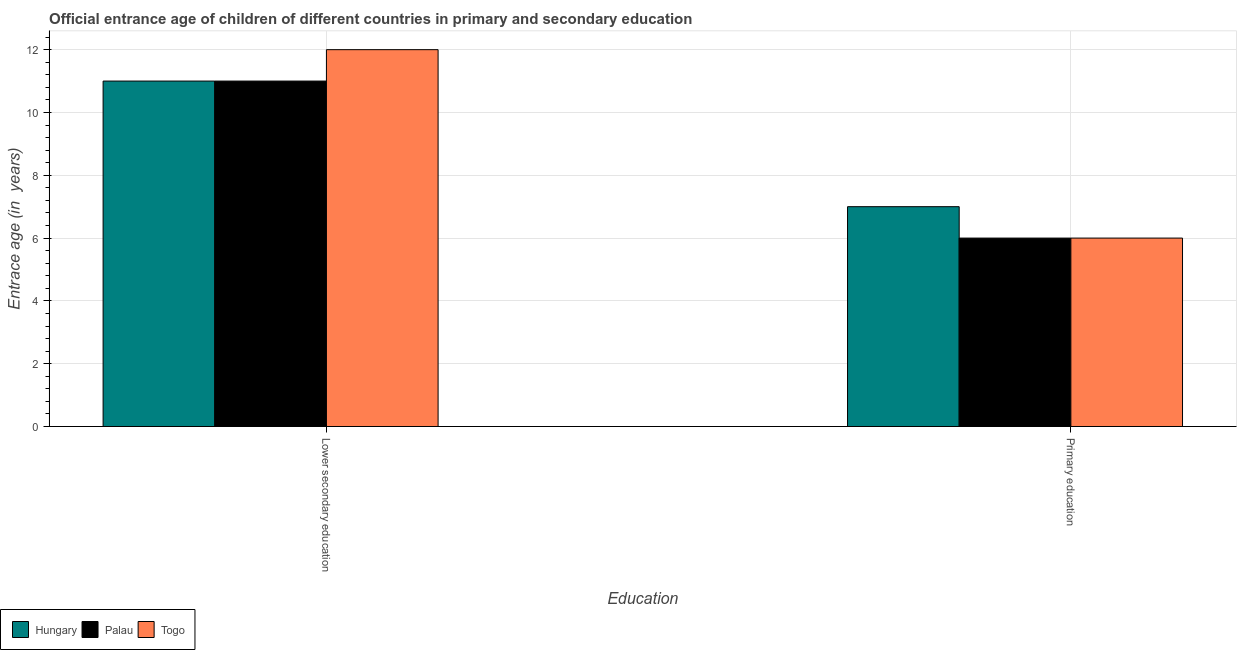How many bars are there on the 1st tick from the right?
Provide a short and direct response. 3. What is the entrance age of children in lower secondary education in Togo?
Make the answer very short. 12. Across all countries, what is the maximum entrance age of chiildren in primary education?
Your answer should be compact. 7. In which country was the entrance age of children in lower secondary education maximum?
Offer a very short reply. Togo. In which country was the entrance age of children in lower secondary education minimum?
Give a very brief answer. Hungary. What is the total entrance age of children in lower secondary education in the graph?
Your answer should be compact. 34. What is the difference between the entrance age of children in lower secondary education in Hungary and that in Togo?
Your answer should be very brief. -1. What is the average entrance age of children in lower secondary education per country?
Ensure brevity in your answer.  11.33. What is the difference between the entrance age of children in lower secondary education and entrance age of chiildren in primary education in Togo?
Provide a succinct answer. 6. In how many countries, is the entrance age of children in lower secondary education greater than 6.8 years?
Your answer should be very brief. 3. What does the 2nd bar from the left in Primary education represents?
Make the answer very short. Palau. What does the 2nd bar from the right in Primary education represents?
Your response must be concise. Palau. Are all the bars in the graph horizontal?
Your response must be concise. No. How many countries are there in the graph?
Keep it short and to the point. 3. Are the values on the major ticks of Y-axis written in scientific E-notation?
Make the answer very short. No. Does the graph contain any zero values?
Provide a short and direct response. No. Where does the legend appear in the graph?
Your answer should be compact. Bottom left. How many legend labels are there?
Offer a terse response. 3. How are the legend labels stacked?
Give a very brief answer. Horizontal. What is the title of the graph?
Your answer should be compact. Official entrance age of children of different countries in primary and secondary education. Does "Luxembourg" appear as one of the legend labels in the graph?
Make the answer very short. No. What is the label or title of the X-axis?
Provide a short and direct response. Education. What is the label or title of the Y-axis?
Provide a short and direct response. Entrace age (in  years). What is the Entrace age (in  years) of Hungary in Lower secondary education?
Your answer should be compact. 11. What is the Entrace age (in  years) in Palau in Lower secondary education?
Your response must be concise. 11. What is the Entrace age (in  years) of Togo in Lower secondary education?
Make the answer very short. 12. What is the Entrace age (in  years) in Palau in Primary education?
Ensure brevity in your answer.  6. Across all Education, what is the maximum Entrace age (in  years) of Hungary?
Your answer should be very brief. 11. Across all Education, what is the maximum Entrace age (in  years) in Palau?
Offer a very short reply. 11. Across all Education, what is the minimum Entrace age (in  years) in Palau?
Make the answer very short. 6. What is the total Entrace age (in  years) in Hungary in the graph?
Give a very brief answer. 18. What is the difference between the Entrace age (in  years) of Togo in Lower secondary education and that in Primary education?
Provide a short and direct response. 6. What is the difference between the Entrace age (in  years) of Hungary in Lower secondary education and the Entrace age (in  years) of Palau in Primary education?
Your answer should be very brief. 5. What is the difference between the Entrace age (in  years) of Hungary in Lower secondary education and the Entrace age (in  years) of Togo in Primary education?
Provide a succinct answer. 5. What is the average Entrace age (in  years) in Togo per Education?
Your response must be concise. 9. What is the difference between the Entrace age (in  years) of Hungary and Entrace age (in  years) of Palau in Lower secondary education?
Your answer should be very brief. 0. What is the difference between the Entrace age (in  years) of Hungary and Entrace age (in  years) of Togo in Lower secondary education?
Your answer should be compact. -1. What is the difference between the Entrace age (in  years) of Palau and Entrace age (in  years) of Togo in Lower secondary education?
Provide a succinct answer. -1. What is the difference between the Entrace age (in  years) in Hungary and Entrace age (in  years) in Togo in Primary education?
Provide a short and direct response. 1. What is the difference between the Entrace age (in  years) in Palau and Entrace age (in  years) in Togo in Primary education?
Offer a terse response. 0. What is the ratio of the Entrace age (in  years) in Hungary in Lower secondary education to that in Primary education?
Make the answer very short. 1.57. What is the ratio of the Entrace age (in  years) of Palau in Lower secondary education to that in Primary education?
Give a very brief answer. 1.83. What is the ratio of the Entrace age (in  years) in Togo in Lower secondary education to that in Primary education?
Your answer should be compact. 2. What is the difference between the highest and the second highest Entrace age (in  years) in Palau?
Your answer should be compact. 5. What is the difference between the highest and the second highest Entrace age (in  years) of Togo?
Offer a very short reply. 6. What is the difference between the highest and the lowest Entrace age (in  years) in Hungary?
Your answer should be compact. 4. What is the difference between the highest and the lowest Entrace age (in  years) in Palau?
Provide a short and direct response. 5. What is the difference between the highest and the lowest Entrace age (in  years) of Togo?
Your response must be concise. 6. 